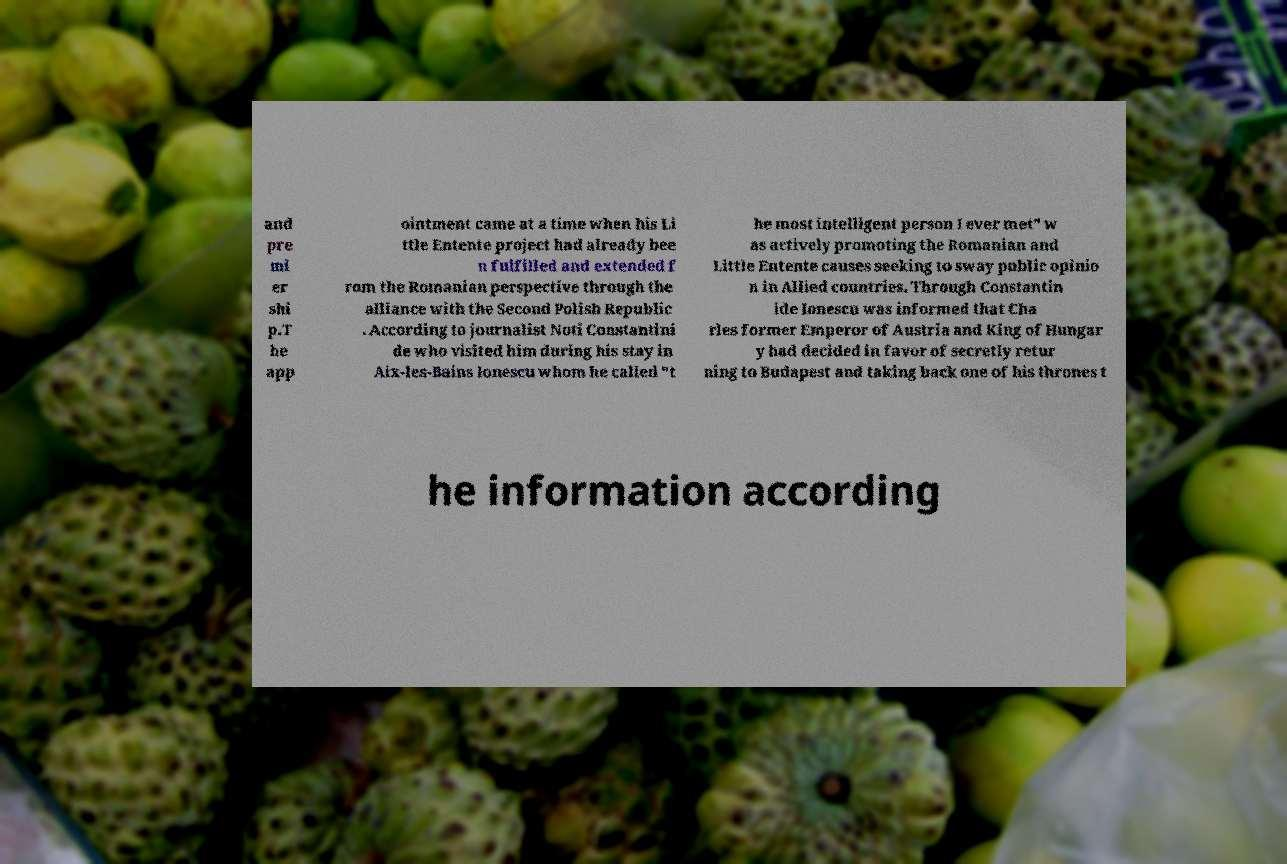I need the written content from this picture converted into text. Can you do that? and pre mi er shi p.T he app ointment came at a time when his Li ttle Entente project had already bee n fulfilled and extended f rom the Romanian perspective through the alliance with the Second Polish Republic . According to journalist Noti Constantini de who visited him during his stay in Aix-les-Bains Ionescu whom he called "t he most intelligent person I ever met" w as actively promoting the Romanian and Little Entente causes seeking to sway public opinio n in Allied countries. Through Constantin ide Ionescu was informed that Cha rles former Emperor of Austria and King of Hungar y had decided in favor of secretly retur ning to Budapest and taking back one of his thrones t he information according 